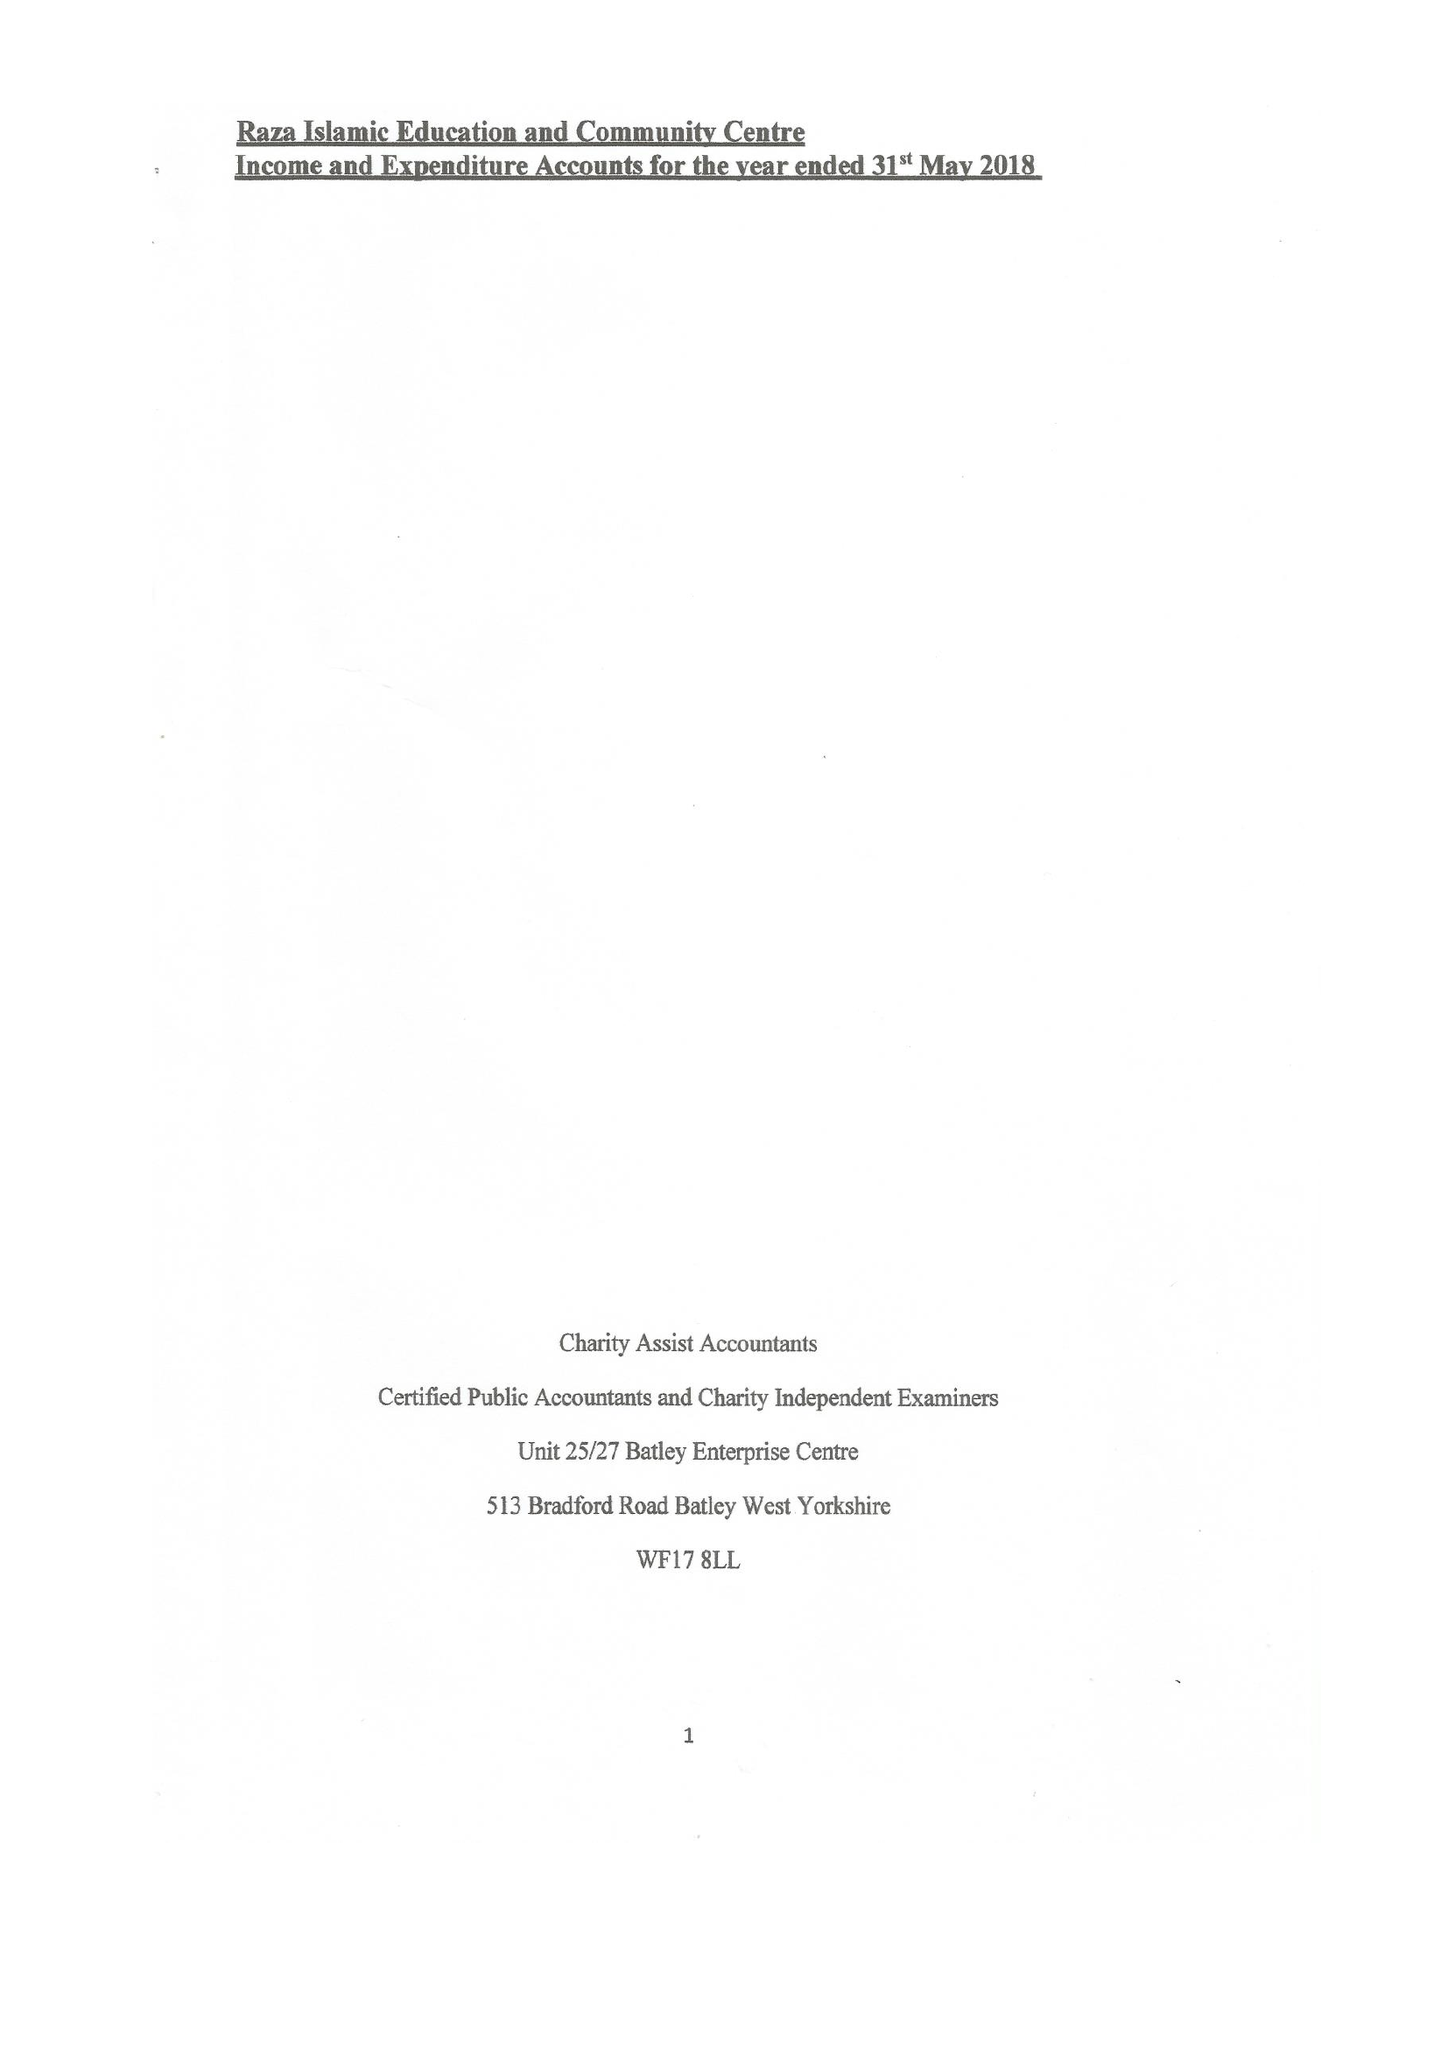What is the value for the address__post_town?
Answer the question using a single word or phrase. DEWSBURY 